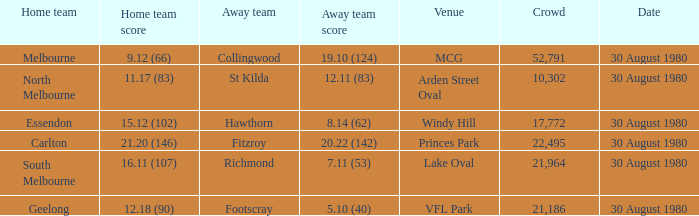What was the score for south melbourne at home? 16.11 (107). 